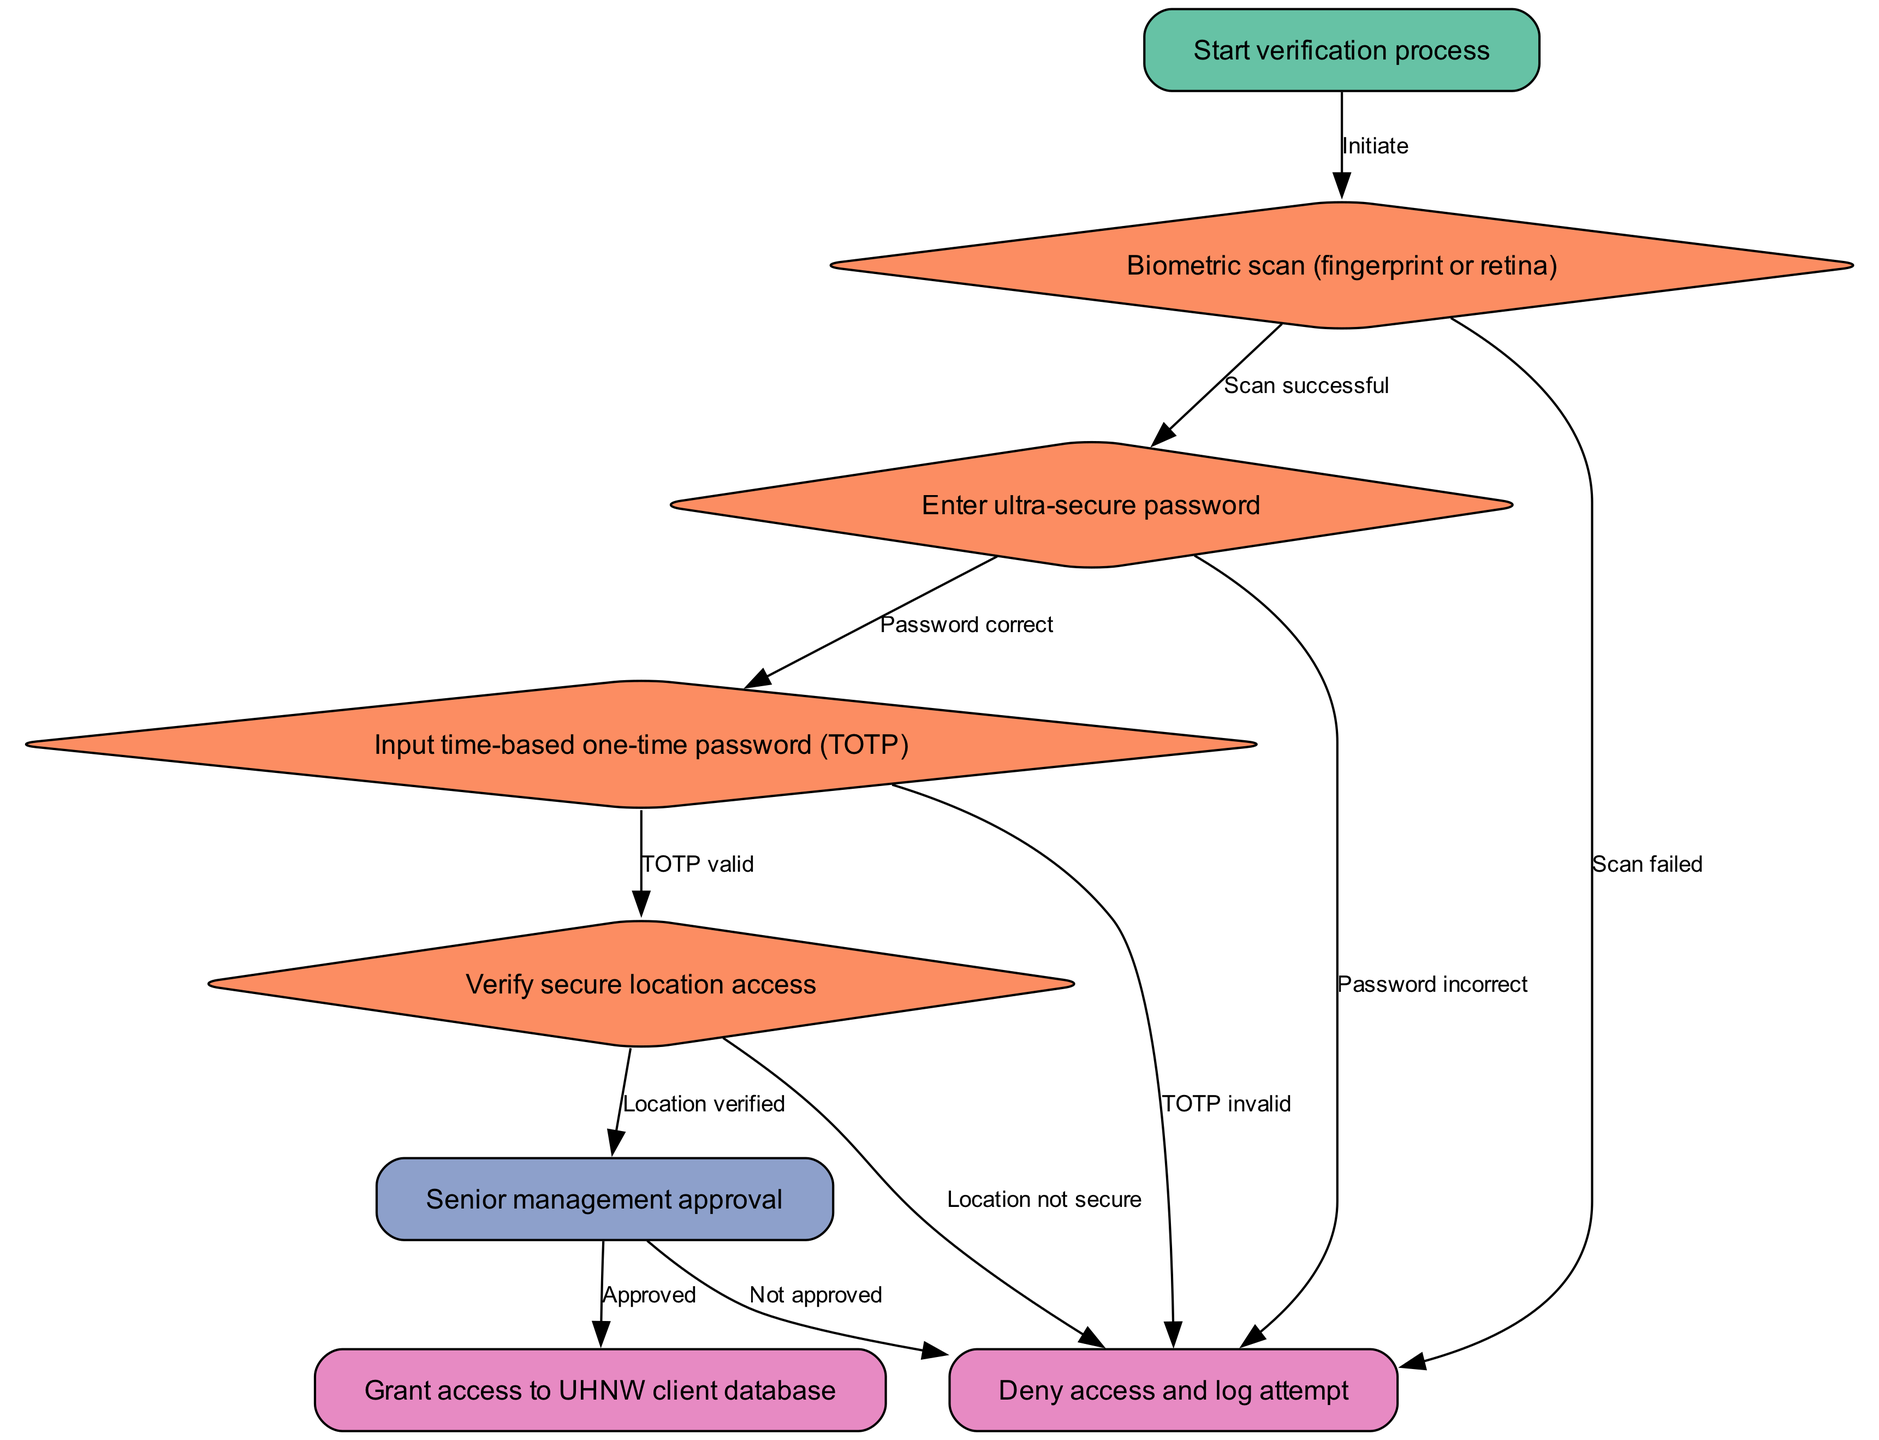What is the first step in the verification process? The diagram starts with the "Start verification process" node, which is the first step in the flowchart.
Answer: Start verification process How many nodes are there in the diagram? By counting each node defined in the data, there are a total of 8 nodes including start, biometric, password, token, location, approval, access, and deny.
Answer: 8 What happens after a successful biometric scan? According to the diagram, after a successful biometric scan, the process moves from the "Biometric scan" node to the "Enter ultra-secure password" node.
Answer: Enter ultra-secure password What are the possible outcomes of an incorrect password? The diagram indicates that if the password is incorrect, the flow will go to the "Deny access and log attempt" node. This is a direct outcome of the password verification step.
Answer: Deny access and log attempt Which step comes before granting access to the UHNW client database? The flowchart shows that "Senior management approval" is the direct step before "Grant access to UHNW client database." This means management must approve access prior to it being granted.
Answer: Senior management approval If the TOTP is invalid, what is the outcome? According to the flowchart, if the TOTP (time-based one-time password) is invalid, the process moves to "Deny access and log attempt," which signifies that access is not granted.
Answer: Deny access and log attempt What locational check is performed in the process? The diagram features a specific step titled "Verify secure location access," which reflects the necessary check regarding the client's secure location during verification.
Answer: Verify secure location access What color represents the decision nodes in the diagram? The decision nodes, which include biometric, password, token, and location, are represented in a specific color scheme and are filled with the color #fc8d62.
Answer: #fc8d62 